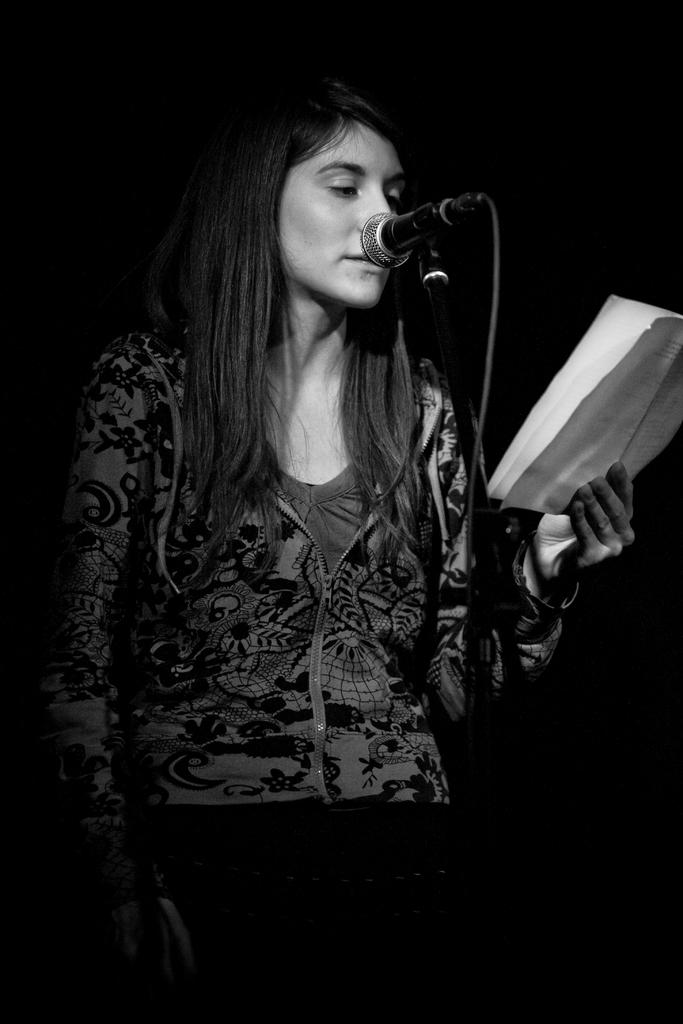What is the person in the image doing? The person is standing and holding a paper. What is the person looking at in the image? The person is looking at the paper they are holding. What object is in front of the person in the image? There is a microphone in front of the person. What type of zephyr can be seen blowing through the person's hair in the image? There is no zephyr present in the image, and the person's hair is not being blown by any wind. 